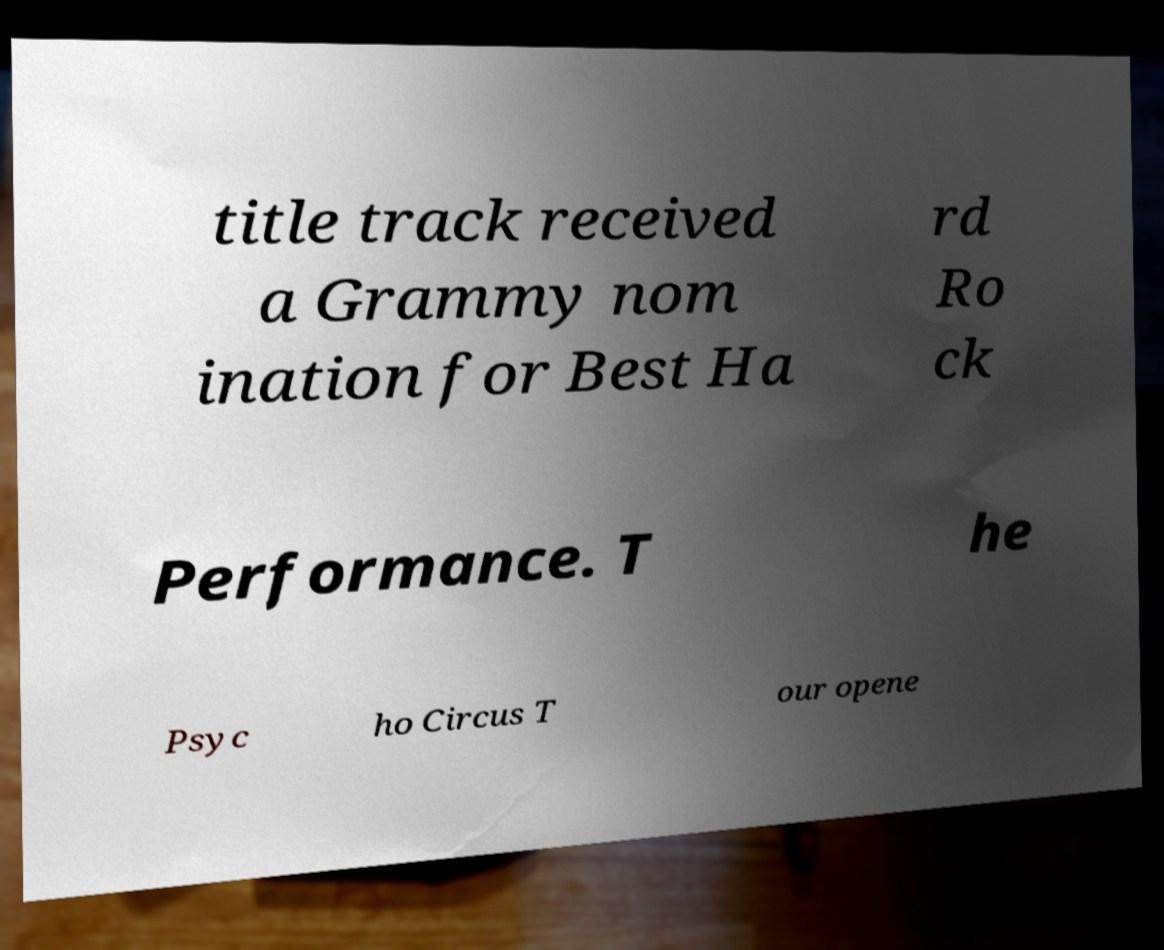I need the written content from this picture converted into text. Can you do that? title track received a Grammy nom ination for Best Ha rd Ro ck Performance. T he Psyc ho Circus T our opene 